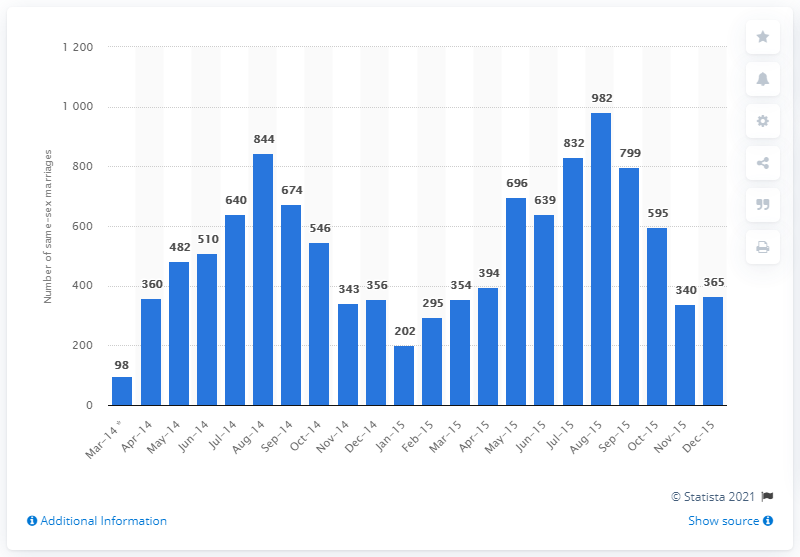Draw attention to some important aspects in this diagram. Ninety-eight couples got married in the first three days of same-sex marriage. 